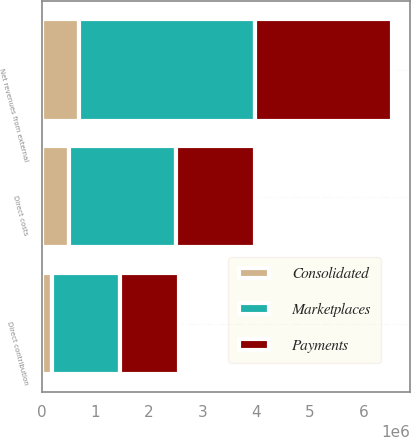<chart> <loc_0><loc_0><loc_500><loc_500><stacked_bar_chart><ecel><fcel>Net revenues from external<fcel>Direct costs<fcel>Direct contribution<nl><fcel>Payments<fcel>2.57361e+06<fcel>1.47696e+06<fcel>1.09664e+06<nl><fcel>Consolidated<fcel>697702<fcel>512946<fcel>184756<nl><fcel>Marketplaces<fcel>3.27131e+06<fcel>1.98991e+06<fcel>1.2814e+06<nl></chart> 